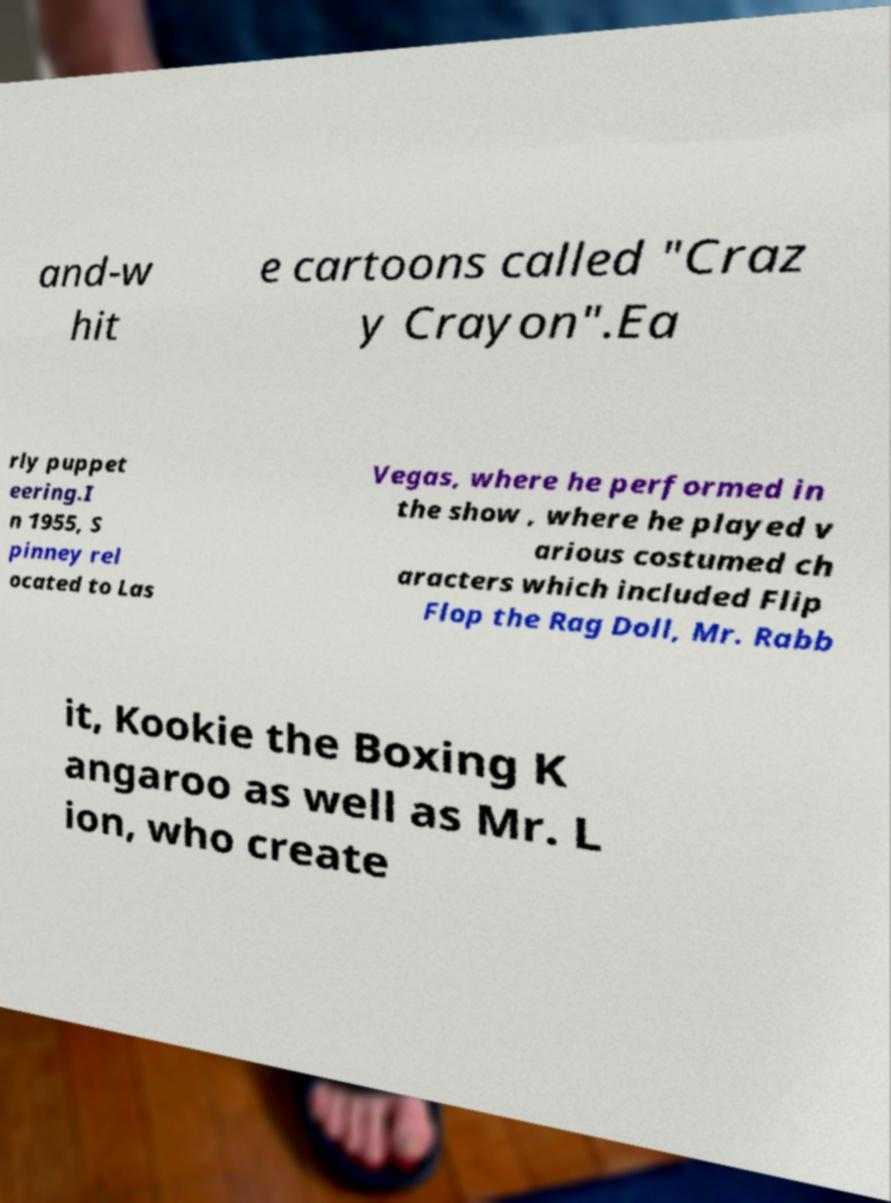Please read and relay the text visible in this image. What does it say? and-w hit e cartoons called "Craz y Crayon".Ea rly puppet eering.I n 1955, S pinney rel ocated to Las Vegas, where he performed in the show , where he played v arious costumed ch aracters which included Flip Flop the Rag Doll, Mr. Rabb it, Kookie the Boxing K angaroo as well as Mr. L ion, who create 